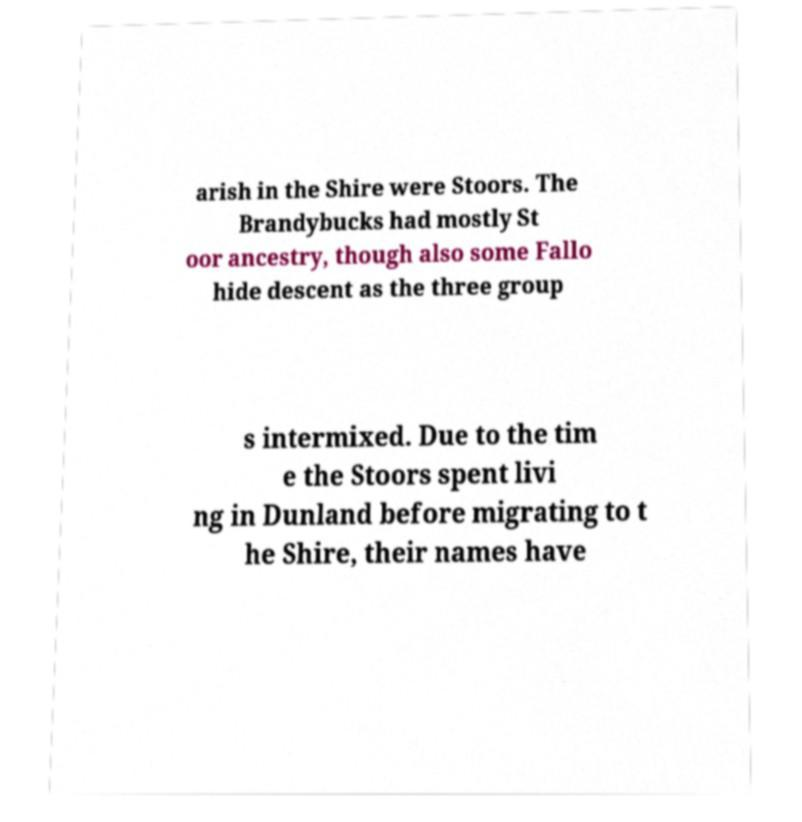There's text embedded in this image that I need extracted. Can you transcribe it verbatim? arish in the Shire were Stoors. The Brandybucks had mostly St oor ancestry, though also some Fallo hide descent as the three group s intermixed. Due to the tim e the Stoors spent livi ng in Dunland before migrating to t he Shire, their names have 